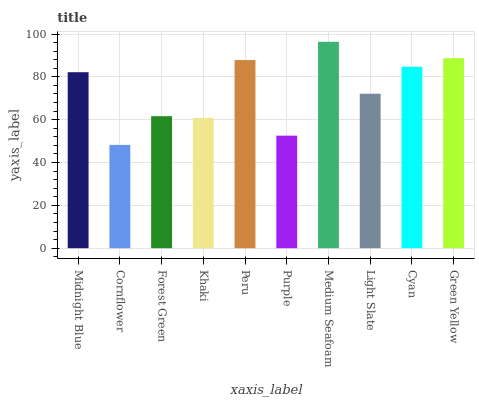Is Forest Green the minimum?
Answer yes or no. No. Is Forest Green the maximum?
Answer yes or no. No. Is Forest Green greater than Cornflower?
Answer yes or no. Yes. Is Cornflower less than Forest Green?
Answer yes or no. Yes. Is Cornflower greater than Forest Green?
Answer yes or no. No. Is Forest Green less than Cornflower?
Answer yes or no. No. Is Midnight Blue the high median?
Answer yes or no. Yes. Is Light Slate the low median?
Answer yes or no. Yes. Is Forest Green the high median?
Answer yes or no. No. Is Green Yellow the low median?
Answer yes or no. No. 